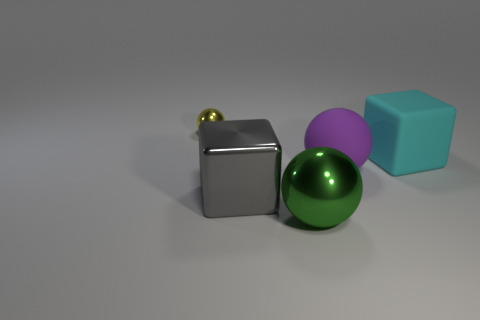There is a metal sphere in front of the yellow metallic sphere; is it the same color as the large matte cube?
Provide a short and direct response. No. How many cylinders are small things or purple matte objects?
Offer a terse response. 0. What is the size of the block that is on the left side of the metallic sphere that is in front of the ball behind the large cyan cube?
Offer a very short reply. Large. There is a gray object that is the same size as the cyan matte object; what shape is it?
Provide a succinct answer. Cube. What shape is the yellow metal object?
Make the answer very short. Sphere. Do the sphere in front of the metallic block and the cyan object have the same material?
Ensure brevity in your answer.  No. There is a metal ball that is on the right side of the metal sphere that is behind the big gray metallic block; what size is it?
Provide a succinct answer. Large. What color is the object that is both left of the large cyan thing and behind the large rubber ball?
Offer a terse response. Yellow. There is a gray object that is the same size as the purple ball; what is it made of?
Provide a short and direct response. Metal. What number of other things are the same material as the small thing?
Make the answer very short. 2. 